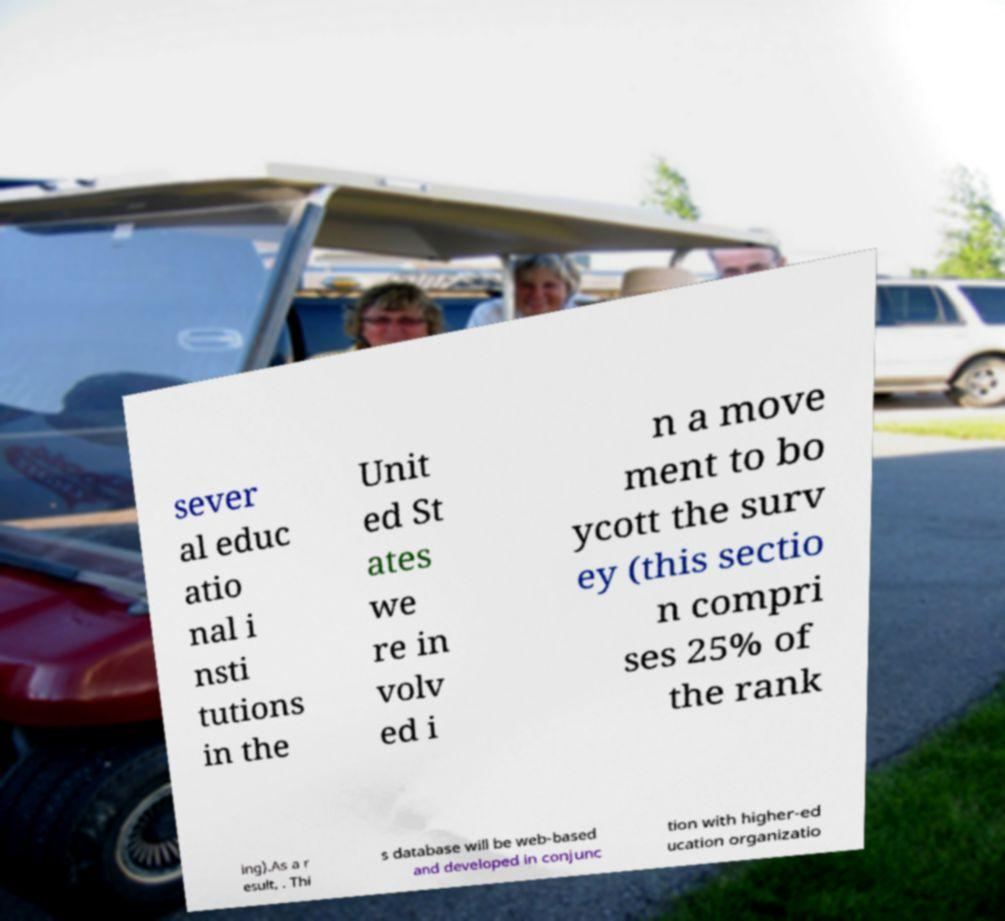Please identify and transcribe the text found in this image. sever al educ atio nal i nsti tutions in the Unit ed St ates we re in volv ed i n a move ment to bo ycott the surv ey (this sectio n compri ses 25% of the rank ing).As a r esult, . Thi s database will be web-based and developed in conjunc tion with higher-ed ucation organizatio 